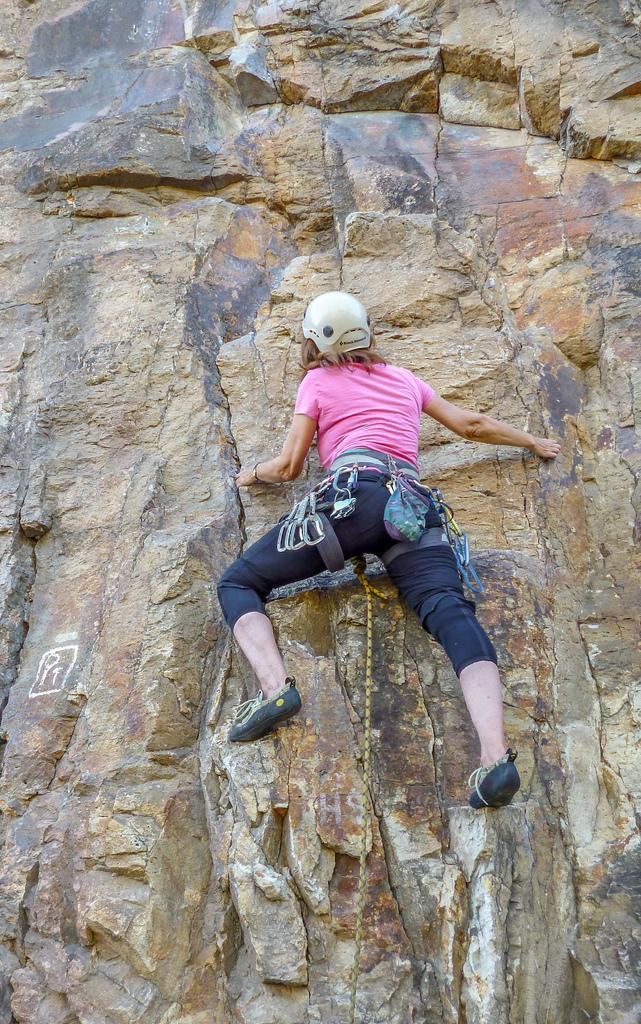Please provide a concise description of this image. In this picture we can see a person climbing a mountain. 